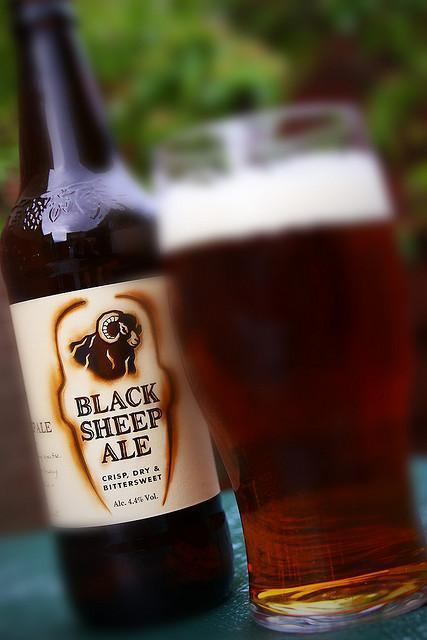How many bushes are to the left of the woman on the park bench?
Give a very brief answer. 0. 